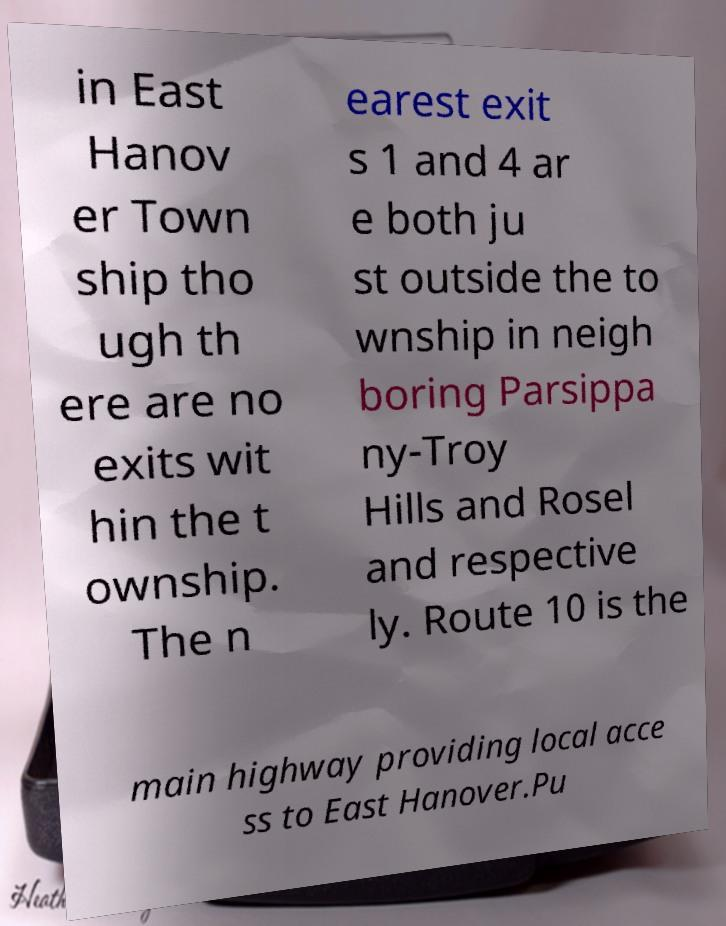For documentation purposes, I need the text within this image transcribed. Could you provide that? in East Hanov er Town ship tho ugh th ere are no exits wit hin the t ownship. The n earest exit s 1 and 4 ar e both ju st outside the to wnship in neigh boring Parsippa ny-Troy Hills and Rosel and respective ly. Route 10 is the main highway providing local acce ss to East Hanover.Pu 